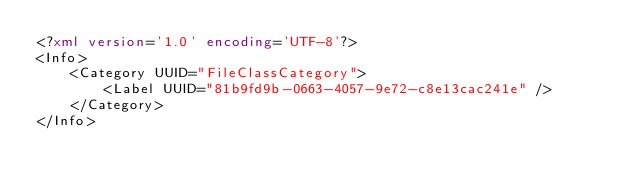<code> <loc_0><loc_0><loc_500><loc_500><_XML_><?xml version='1.0' encoding='UTF-8'?>
<Info>
    <Category UUID="FileClassCategory">
        <Label UUID="81b9fd9b-0663-4057-9e72-c8e13cac241e" />
    </Category>
</Info></code> 